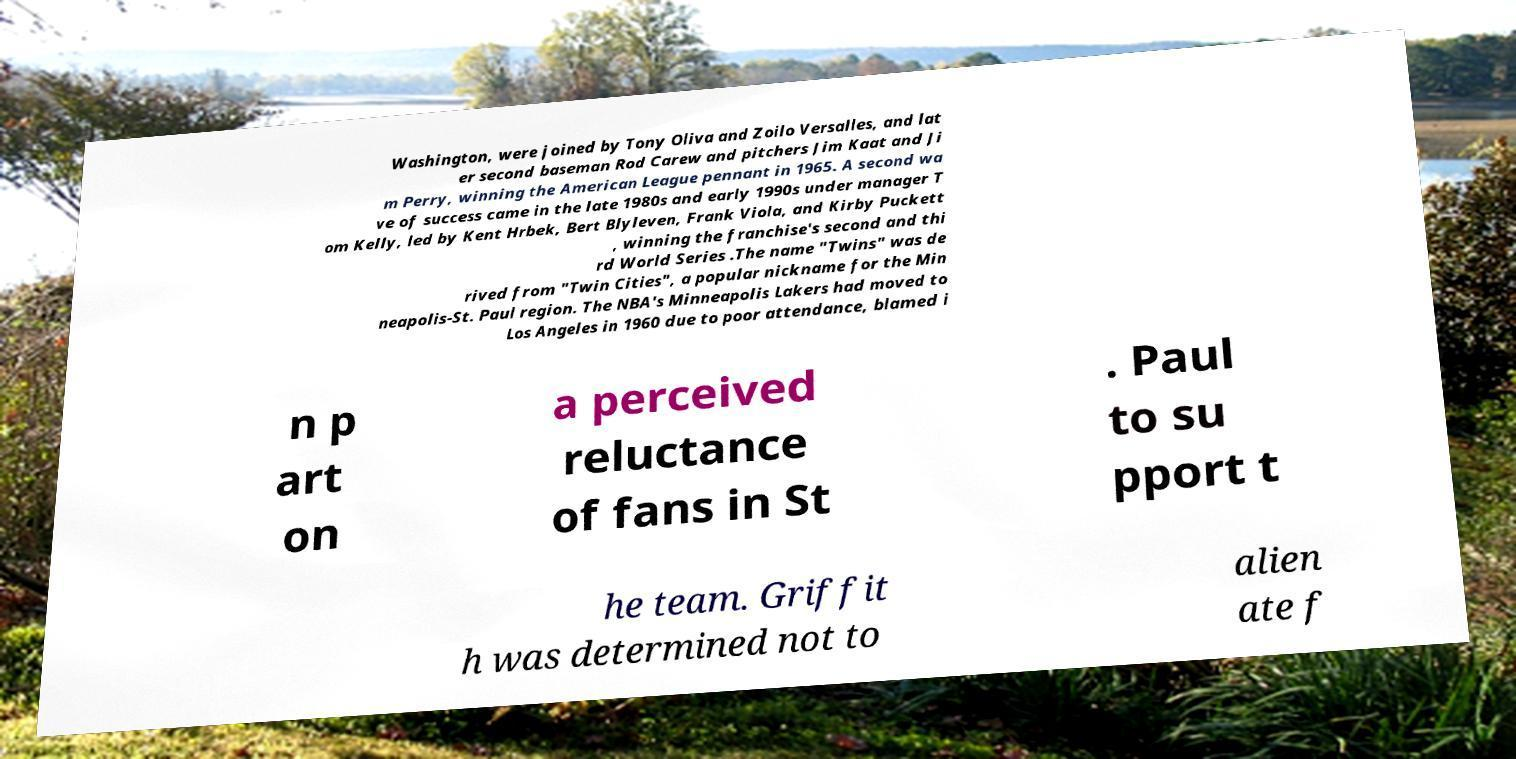Could you assist in decoding the text presented in this image and type it out clearly? Washington, were joined by Tony Oliva and Zoilo Versalles, and lat er second baseman Rod Carew and pitchers Jim Kaat and Ji m Perry, winning the American League pennant in 1965. A second wa ve of success came in the late 1980s and early 1990s under manager T om Kelly, led by Kent Hrbek, Bert Blyleven, Frank Viola, and Kirby Puckett , winning the franchise's second and thi rd World Series .The name "Twins" was de rived from "Twin Cities", a popular nickname for the Min neapolis-St. Paul region. The NBA's Minneapolis Lakers had moved to Los Angeles in 1960 due to poor attendance, blamed i n p art on a perceived reluctance of fans in St . Paul to su pport t he team. Griffit h was determined not to alien ate f 